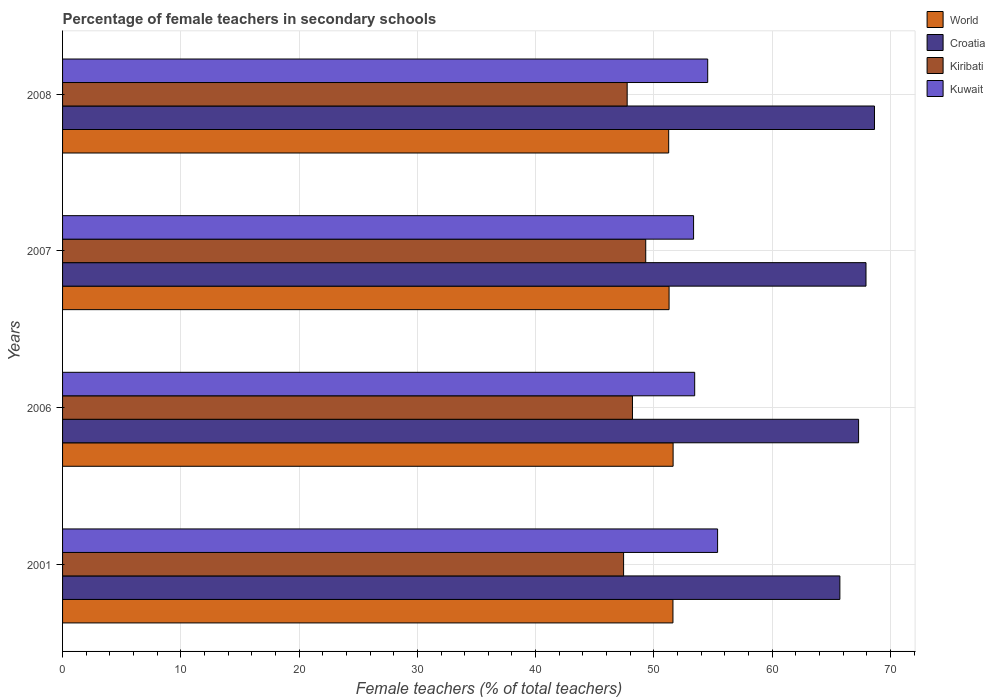How many different coloured bars are there?
Your response must be concise. 4. How many groups of bars are there?
Provide a short and direct response. 4. Are the number of bars per tick equal to the number of legend labels?
Ensure brevity in your answer.  Yes. How many bars are there on the 3rd tick from the top?
Your answer should be compact. 4. How many bars are there on the 3rd tick from the bottom?
Offer a very short reply. 4. In how many cases, is the number of bars for a given year not equal to the number of legend labels?
Ensure brevity in your answer.  0. What is the percentage of female teachers in Kiribati in 2001?
Your answer should be compact. 47.44. Across all years, what is the maximum percentage of female teachers in Croatia?
Ensure brevity in your answer.  68.65. Across all years, what is the minimum percentage of female teachers in Kuwait?
Provide a succinct answer. 53.36. What is the total percentage of female teachers in Kiribati in the graph?
Make the answer very short. 192.68. What is the difference between the percentage of female teachers in Kiribati in 2001 and that in 2007?
Give a very brief answer. -1.87. What is the difference between the percentage of female teachers in Kuwait in 2006 and the percentage of female teachers in Croatia in 2008?
Offer a very short reply. -15.2. What is the average percentage of female teachers in World per year?
Your answer should be compact. 51.44. In the year 2008, what is the difference between the percentage of female teachers in Croatia and percentage of female teachers in Kuwait?
Offer a terse response. 14.1. In how many years, is the percentage of female teachers in Kiribati greater than 44 %?
Your response must be concise. 4. What is the ratio of the percentage of female teachers in World in 2001 to that in 2008?
Give a very brief answer. 1.01. Is the difference between the percentage of female teachers in Croatia in 2007 and 2008 greater than the difference between the percentage of female teachers in Kuwait in 2007 and 2008?
Give a very brief answer. Yes. What is the difference between the highest and the second highest percentage of female teachers in Croatia?
Provide a short and direct response. 0.72. What is the difference between the highest and the lowest percentage of female teachers in Kiribati?
Provide a succinct answer. 1.87. In how many years, is the percentage of female teachers in World greater than the average percentage of female teachers in World taken over all years?
Give a very brief answer. 2. Is it the case that in every year, the sum of the percentage of female teachers in World and percentage of female teachers in Croatia is greater than the sum of percentage of female teachers in Kiribati and percentage of female teachers in Kuwait?
Your answer should be compact. Yes. What does the 2nd bar from the top in 2007 represents?
Make the answer very short. Kiribati. What does the 2nd bar from the bottom in 2001 represents?
Make the answer very short. Croatia. How many bars are there?
Your answer should be compact. 16. Are all the bars in the graph horizontal?
Your answer should be very brief. Yes. How are the legend labels stacked?
Your answer should be very brief. Vertical. What is the title of the graph?
Your answer should be very brief. Percentage of female teachers in secondary schools. Does "Uganda" appear as one of the legend labels in the graph?
Ensure brevity in your answer.  No. What is the label or title of the X-axis?
Offer a very short reply. Female teachers (% of total teachers). What is the Female teachers (% of total teachers) in World in 2001?
Offer a very short reply. 51.61. What is the Female teachers (% of total teachers) of Croatia in 2001?
Offer a very short reply. 65.73. What is the Female teachers (% of total teachers) in Kiribati in 2001?
Make the answer very short. 47.44. What is the Female teachers (% of total teachers) of Kuwait in 2001?
Make the answer very short. 55.39. What is the Female teachers (% of total teachers) of World in 2006?
Offer a very short reply. 51.62. What is the Female teachers (% of total teachers) in Croatia in 2006?
Give a very brief answer. 67.31. What is the Female teachers (% of total teachers) in Kiribati in 2006?
Your answer should be compact. 48.19. What is the Female teachers (% of total teachers) in Kuwait in 2006?
Give a very brief answer. 53.45. What is the Female teachers (% of total teachers) of World in 2007?
Offer a terse response. 51.28. What is the Female teachers (% of total teachers) of Croatia in 2007?
Provide a succinct answer. 67.93. What is the Female teachers (% of total teachers) in Kiribati in 2007?
Ensure brevity in your answer.  49.31. What is the Female teachers (% of total teachers) of Kuwait in 2007?
Ensure brevity in your answer.  53.36. What is the Female teachers (% of total teachers) in World in 2008?
Provide a short and direct response. 51.25. What is the Female teachers (% of total teachers) of Croatia in 2008?
Provide a short and direct response. 68.65. What is the Female teachers (% of total teachers) of Kiribati in 2008?
Your answer should be very brief. 47.74. What is the Female teachers (% of total teachers) in Kuwait in 2008?
Your answer should be compact. 54.55. Across all years, what is the maximum Female teachers (% of total teachers) in World?
Your response must be concise. 51.62. Across all years, what is the maximum Female teachers (% of total teachers) in Croatia?
Your response must be concise. 68.65. Across all years, what is the maximum Female teachers (% of total teachers) of Kiribati?
Provide a succinct answer. 49.31. Across all years, what is the maximum Female teachers (% of total teachers) in Kuwait?
Ensure brevity in your answer.  55.39. Across all years, what is the minimum Female teachers (% of total teachers) of World?
Provide a short and direct response. 51.25. Across all years, what is the minimum Female teachers (% of total teachers) of Croatia?
Give a very brief answer. 65.73. Across all years, what is the minimum Female teachers (% of total teachers) in Kiribati?
Your response must be concise. 47.44. Across all years, what is the minimum Female teachers (% of total teachers) in Kuwait?
Offer a very short reply. 53.36. What is the total Female teachers (% of total teachers) of World in the graph?
Give a very brief answer. 205.77. What is the total Female teachers (% of total teachers) of Croatia in the graph?
Give a very brief answer. 269.62. What is the total Female teachers (% of total teachers) of Kiribati in the graph?
Make the answer very short. 192.68. What is the total Female teachers (% of total teachers) of Kuwait in the graph?
Offer a very short reply. 216.74. What is the difference between the Female teachers (% of total teachers) in World in 2001 and that in 2006?
Your response must be concise. -0.01. What is the difference between the Female teachers (% of total teachers) in Croatia in 2001 and that in 2006?
Provide a succinct answer. -1.58. What is the difference between the Female teachers (% of total teachers) in Kiribati in 2001 and that in 2006?
Your answer should be compact. -0.75. What is the difference between the Female teachers (% of total teachers) in Kuwait in 2001 and that in 2006?
Ensure brevity in your answer.  1.94. What is the difference between the Female teachers (% of total teachers) in World in 2001 and that in 2007?
Offer a very short reply. 0.33. What is the difference between the Female teachers (% of total teachers) in Croatia in 2001 and that in 2007?
Your answer should be compact. -2.21. What is the difference between the Female teachers (% of total teachers) in Kiribati in 2001 and that in 2007?
Make the answer very short. -1.87. What is the difference between the Female teachers (% of total teachers) in Kuwait in 2001 and that in 2007?
Provide a short and direct response. 2.03. What is the difference between the Female teachers (% of total teachers) of World in 2001 and that in 2008?
Your response must be concise. 0.36. What is the difference between the Female teachers (% of total teachers) of Croatia in 2001 and that in 2008?
Give a very brief answer. -2.93. What is the difference between the Female teachers (% of total teachers) in Kiribati in 2001 and that in 2008?
Your answer should be compact. -0.3. What is the difference between the Female teachers (% of total teachers) in Kuwait in 2001 and that in 2008?
Keep it short and to the point. 0.84. What is the difference between the Female teachers (% of total teachers) of World in 2006 and that in 2007?
Offer a very short reply. 0.34. What is the difference between the Female teachers (% of total teachers) of Croatia in 2006 and that in 2007?
Give a very brief answer. -0.63. What is the difference between the Female teachers (% of total teachers) in Kiribati in 2006 and that in 2007?
Make the answer very short. -1.12. What is the difference between the Female teachers (% of total teachers) in Kuwait in 2006 and that in 2007?
Your answer should be compact. 0.09. What is the difference between the Female teachers (% of total teachers) in World in 2006 and that in 2008?
Offer a very short reply. 0.37. What is the difference between the Female teachers (% of total teachers) of Croatia in 2006 and that in 2008?
Provide a succinct answer. -1.34. What is the difference between the Female teachers (% of total teachers) in Kiribati in 2006 and that in 2008?
Ensure brevity in your answer.  0.45. What is the difference between the Female teachers (% of total teachers) of Kuwait in 2006 and that in 2008?
Your response must be concise. -1.1. What is the difference between the Female teachers (% of total teachers) in World in 2007 and that in 2008?
Offer a very short reply. 0.03. What is the difference between the Female teachers (% of total teachers) of Croatia in 2007 and that in 2008?
Your response must be concise. -0.72. What is the difference between the Female teachers (% of total teachers) in Kiribati in 2007 and that in 2008?
Provide a short and direct response. 1.57. What is the difference between the Female teachers (% of total teachers) in Kuwait in 2007 and that in 2008?
Offer a terse response. -1.19. What is the difference between the Female teachers (% of total teachers) of World in 2001 and the Female teachers (% of total teachers) of Croatia in 2006?
Your answer should be compact. -15.7. What is the difference between the Female teachers (% of total teachers) in World in 2001 and the Female teachers (% of total teachers) in Kiribati in 2006?
Offer a terse response. 3.42. What is the difference between the Female teachers (% of total teachers) in World in 2001 and the Female teachers (% of total teachers) in Kuwait in 2006?
Your response must be concise. -1.84. What is the difference between the Female teachers (% of total teachers) of Croatia in 2001 and the Female teachers (% of total teachers) of Kiribati in 2006?
Offer a very short reply. 17.54. What is the difference between the Female teachers (% of total teachers) in Croatia in 2001 and the Female teachers (% of total teachers) in Kuwait in 2006?
Provide a succinct answer. 12.28. What is the difference between the Female teachers (% of total teachers) in Kiribati in 2001 and the Female teachers (% of total teachers) in Kuwait in 2006?
Offer a terse response. -6.01. What is the difference between the Female teachers (% of total teachers) of World in 2001 and the Female teachers (% of total teachers) of Croatia in 2007?
Ensure brevity in your answer.  -16.32. What is the difference between the Female teachers (% of total teachers) of World in 2001 and the Female teachers (% of total teachers) of Kiribati in 2007?
Your answer should be very brief. 2.3. What is the difference between the Female teachers (% of total teachers) in World in 2001 and the Female teachers (% of total teachers) in Kuwait in 2007?
Keep it short and to the point. -1.74. What is the difference between the Female teachers (% of total teachers) in Croatia in 2001 and the Female teachers (% of total teachers) in Kiribati in 2007?
Keep it short and to the point. 16.42. What is the difference between the Female teachers (% of total teachers) in Croatia in 2001 and the Female teachers (% of total teachers) in Kuwait in 2007?
Your answer should be very brief. 12.37. What is the difference between the Female teachers (% of total teachers) of Kiribati in 2001 and the Female teachers (% of total teachers) of Kuwait in 2007?
Your answer should be compact. -5.92. What is the difference between the Female teachers (% of total teachers) of World in 2001 and the Female teachers (% of total teachers) of Croatia in 2008?
Your response must be concise. -17.04. What is the difference between the Female teachers (% of total teachers) of World in 2001 and the Female teachers (% of total teachers) of Kiribati in 2008?
Make the answer very short. 3.87. What is the difference between the Female teachers (% of total teachers) in World in 2001 and the Female teachers (% of total teachers) in Kuwait in 2008?
Give a very brief answer. -2.94. What is the difference between the Female teachers (% of total teachers) in Croatia in 2001 and the Female teachers (% of total teachers) in Kiribati in 2008?
Your answer should be very brief. 17.99. What is the difference between the Female teachers (% of total teachers) of Croatia in 2001 and the Female teachers (% of total teachers) of Kuwait in 2008?
Provide a succinct answer. 11.18. What is the difference between the Female teachers (% of total teachers) of Kiribati in 2001 and the Female teachers (% of total teachers) of Kuwait in 2008?
Ensure brevity in your answer.  -7.11. What is the difference between the Female teachers (% of total teachers) of World in 2006 and the Female teachers (% of total teachers) of Croatia in 2007?
Make the answer very short. -16.31. What is the difference between the Female teachers (% of total teachers) of World in 2006 and the Female teachers (% of total teachers) of Kiribati in 2007?
Your response must be concise. 2.31. What is the difference between the Female teachers (% of total teachers) in World in 2006 and the Female teachers (% of total teachers) in Kuwait in 2007?
Give a very brief answer. -1.73. What is the difference between the Female teachers (% of total teachers) in Croatia in 2006 and the Female teachers (% of total teachers) in Kiribati in 2007?
Offer a terse response. 18. What is the difference between the Female teachers (% of total teachers) of Croatia in 2006 and the Female teachers (% of total teachers) of Kuwait in 2007?
Your answer should be compact. 13.95. What is the difference between the Female teachers (% of total teachers) of Kiribati in 2006 and the Female teachers (% of total teachers) of Kuwait in 2007?
Ensure brevity in your answer.  -5.17. What is the difference between the Female teachers (% of total teachers) in World in 2006 and the Female teachers (% of total teachers) in Croatia in 2008?
Ensure brevity in your answer.  -17.03. What is the difference between the Female teachers (% of total teachers) of World in 2006 and the Female teachers (% of total teachers) of Kiribati in 2008?
Your answer should be very brief. 3.88. What is the difference between the Female teachers (% of total teachers) in World in 2006 and the Female teachers (% of total teachers) in Kuwait in 2008?
Offer a terse response. -2.93. What is the difference between the Female teachers (% of total teachers) of Croatia in 2006 and the Female teachers (% of total teachers) of Kiribati in 2008?
Your answer should be very brief. 19.57. What is the difference between the Female teachers (% of total teachers) in Croatia in 2006 and the Female teachers (% of total teachers) in Kuwait in 2008?
Offer a terse response. 12.76. What is the difference between the Female teachers (% of total teachers) of Kiribati in 2006 and the Female teachers (% of total teachers) of Kuwait in 2008?
Keep it short and to the point. -6.36. What is the difference between the Female teachers (% of total teachers) of World in 2007 and the Female teachers (% of total teachers) of Croatia in 2008?
Offer a very short reply. -17.37. What is the difference between the Female teachers (% of total teachers) of World in 2007 and the Female teachers (% of total teachers) of Kiribati in 2008?
Keep it short and to the point. 3.54. What is the difference between the Female teachers (% of total teachers) in World in 2007 and the Female teachers (% of total teachers) in Kuwait in 2008?
Offer a very short reply. -3.27. What is the difference between the Female teachers (% of total teachers) in Croatia in 2007 and the Female teachers (% of total teachers) in Kiribati in 2008?
Offer a very short reply. 20.19. What is the difference between the Female teachers (% of total teachers) of Croatia in 2007 and the Female teachers (% of total teachers) of Kuwait in 2008?
Make the answer very short. 13.39. What is the difference between the Female teachers (% of total teachers) of Kiribati in 2007 and the Female teachers (% of total teachers) of Kuwait in 2008?
Provide a short and direct response. -5.24. What is the average Female teachers (% of total teachers) in World per year?
Offer a very short reply. 51.44. What is the average Female teachers (% of total teachers) in Croatia per year?
Offer a terse response. 67.41. What is the average Female teachers (% of total teachers) of Kiribati per year?
Give a very brief answer. 48.17. What is the average Female teachers (% of total teachers) in Kuwait per year?
Your answer should be compact. 54.19. In the year 2001, what is the difference between the Female teachers (% of total teachers) in World and Female teachers (% of total teachers) in Croatia?
Make the answer very short. -14.11. In the year 2001, what is the difference between the Female teachers (% of total teachers) of World and Female teachers (% of total teachers) of Kiribati?
Your answer should be very brief. 4.17. In the year 2001, what is the difference between the Female teachers (% of total teachers) in World and Female teachers (% of total teachers) in Kuwait?
Keep it short and to the point. -3.77. In the year 2001, what is the difference between the Female teachers (% of total teachers) of Croatia and Female teachers (% of total teachers) of Kiribati?
Offer a very short reply. 18.29. In the year 2001, what is the difference between the Female teachers (% of total teachers) of Croatia and Female teachers (% of total teachers) of Kuwait?
Your response must be concise. 10.34. In the year 2001, what is the difference between the Female teachers (% of total teachers) in Kiribati and Female teachers (% of total teachers) in Kuwait?
Provide a succinct answer. -7.95. In the year 2006, what is the difference between the Female teachers (% of total teachers) of World and Female teachers (% of total teachers) of Croatia?
Your answer should be very brief. -15.68. In the year 2006, what is the difference between the Female teachers (% of total teachers) of World and Female teachers (% of total teachers) of Kiribati?
Your answer should be very brief. 3.44. In the year 2006, what is the difference between the Female teachers (% of total teachers) in World and Female teachers (% of total teachers) in Kuwait?
Offer a very short reply. -1.82. In the year 2006, what is the difference between the Female teachers (% of total teachers) in Croatia and Female teachers (% of total teachers) in Kiribati?
Provide a short and direct response. 19.12. In the year 2006, what is the difference between the Female teachers (% of total teachers) in Croatia and Female teachers (% of total teachers) in Kuwait?
Provide a succinct answer. 13.86. In the year 2006, what is the difference between the Female teachers (% of total teachers) of Kiribati and Female teachers (% of total teachers) of Kuwait?
Ensure brevity in your answer.  -5.26. In the year 2007, what is the difference between the Female teachers (% of total teachers) in World and Female teachers (% of total teachers) in Croatia?
Your response must be concise. -16.65. In the year 2007, what is the difference between the Female teachers (% of total teachers) of World and Female teachers (% of total teachers) of Kiribati?
Offer a terse response. 1.97. In the year 2007, what is the difference between the Female teachers (% of total teachers) in World and Female teachers (% of total teachers) in Kuwait?
Your response must be concise. -2.07. In the year 2007, what is the difference between the Female teachers (% of total teachers) of Croatia and Female teachers (% of total teachers) of Kiribati?
Your answer should be compact. 18.62. In the year 2007, what is the difference between the Female teachers (% of total teachers) in Croatia and Female teachers (% of total teachers) in Kuwait?
Give a very brief answer. 14.58. In the year 2007, what is the difference between the Female teachers (% of total teachers) of Kiribati and Female teachers (% of total teachers) of Kuwait?
Keep it short and to the point. -4.05. In the year 2008, what is the difference between the Female teachers (% of total teachers) of World and Female teachers (% of total teachers) of Croatia?
Provide a succinct answer. -17.4. In the year 2008, what is the difference between the Female teachers (% of total teachers) of World and Female teachers (% of total teachers) of Kiribati?
Offer a terse response. 3.51. In the year 2008, what is the difference between the Female teachers (% of total teachers) in World and Female teachers (% of total teachers) in Kuwait?
Provide a succinct answer. -3.3. In the year 2008, what is the difference between the Female teachers (% of total teachers) of Croatia and Female teachers (% of total teachers) of Kiribati?
Keep it short and to the point. 20.91. In the year 2008, what is the difference between the Female teachers (% of total teachers) of Croatia and Female teachers (% of total teachers) of Kuwait?
Give a very brief answer. 14.1. In the year 2008, what is the difference between the Female teachers (% of total teachers) in Kiribati and Female teachers (% of total teachers) in Kuwait?
Offer a terse response. -6.81. What is the ratio of the Female teachers (% of total teachers) in Croatia in 2001 to that in 2006?
Your response must be concise. 0.98. What is the ratio of the Female teachers (% of total teachers) of Kiribati in 2001 to that in 2006?
Provide a short and direct response. 0.98. What is the ratio of the Female teachers (% of total teachers) in Kuwait in 2001 to that in 2006?
Ensure brevity in your answer.  1.04. What is the ratio of the Female teachers (% of total teachers) of World in 2001 to that in 2007?
Offer a terse response. 1.01. What is the ratio of the Female teachers (% of total teachers) of Croatia in 2001 to that in 2007?
Provide a succinct answer. 0.97. What is the ratio of the Female teachers (% of total teachers) in Kiribati in 2001 to that in 2007?
Offer a terse response. 0.96. What is the ratio of the Female teachers (% of total teachers) in Kuwait in 2001 to that in 2007?
Your answer should be very brief. 1.04. What is the ratio of the Female teachers (% of total teachers) in Croatia in 2001 to that in 2008?
Provide a short and direct response. 0.96. What is the ratio of the Female teachers (% of total teachers) in Kuwait in 2001 to that in 2008?
Make the answer very short. 1.02. What is the ratio of the Female teachers (% of total teachers) of World in 2006 to that in 2007?
Offer a terse response. 1.01. What is the ratio of the Female teachers (% of total teachers) of Kiribati in 2006 to that in 2007?
Your answer should be compact. 0.98. What is the ratio of the Female teachers (% of total teachers) in World in 2006 to that in 2008?
Your answer should be very brief. 1.01. What is the ratio of the Female teachers (% of total teachers) of Croatia in 2006 to that in 2008?
Make the answer very short. 0.98. What is the ratio of the Female teachers (% of total teachers) in Kiribati in 2006 to that in 2008?
Make the answer very short. 1.01. What is the ratio of the Female teachers (% of total teachers) in Kuwait in 2006 to that in 2008?
Provide a short and direct response. 0.98. What is the ratio of the Female teachers (% of total teachers) in Kiribati in 2007 to that in 2008?
Make the answer very short. 1.03. What is the ratio of the Female teachers (% of total teachers) in Kuwait in 2007 to that in 2008?
Your response must be concise. 0.98. What is the difference between the highest and the second highest Female teachers (% of total teachers) of World?
Your answer should be very brief. 0.01. What is the difference between the highest and the second highest Female teachers (% of total teachers) in Croatia?
Provide a short and direct response. 0.72. What is the difference between the highest and the second highest Female teachers (% of total teachers) of Kiribati?
Your response must be concise. 1.12. What is the difference between the highest and the second highest Female teachers (% of total teachers) in Kuwait?
Ensure brevity in your answer.  0.84. What is the difference between the highest and the lowest Female teachers (% of total teachers) in World?
Make the answer very short. 0.37. What is the difference between the highest and the lowest Female teachers (% of total teachers) in Croatia?
Offer a very short reply. 2.93. What is the difference between the highest and the lowest Female teachers (% of total teachers) of Kiribati?
Provide a succinct answer. 1.87. What is the difference between the highest and the lowest Female teachers (% of total teachers) in Kuwait?
Your response must be concise. 2.03. 